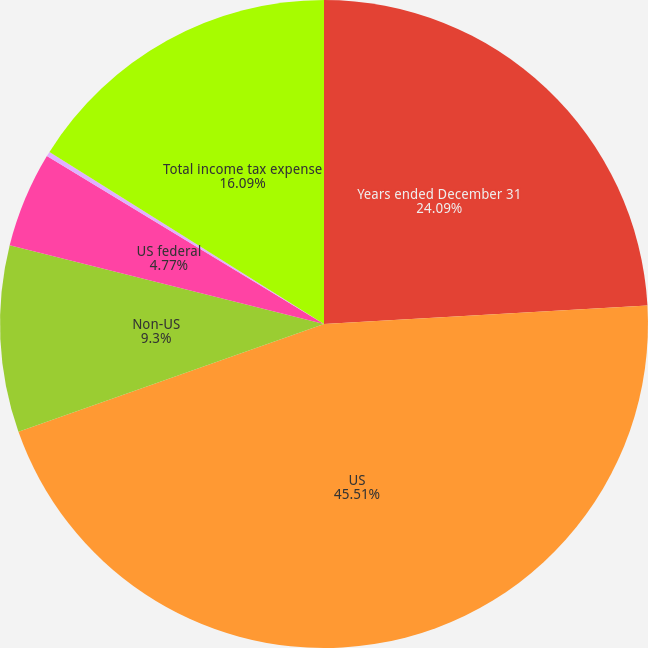Convert chart to OTSL. <chart><loc_0><loc_0><loc_500><loc_500><pie_chart><fcel>Years ended December 31<fcel>US<fcel>Non-US<fcel>US federal<fcel>US state<fcel>Total income tax expense<nl><fcel>24.09%<fcel>45.52%<fcel>9.3%<fcel>4.77%<fcel>0.24%<fcel>16.09%<nl></chart> 